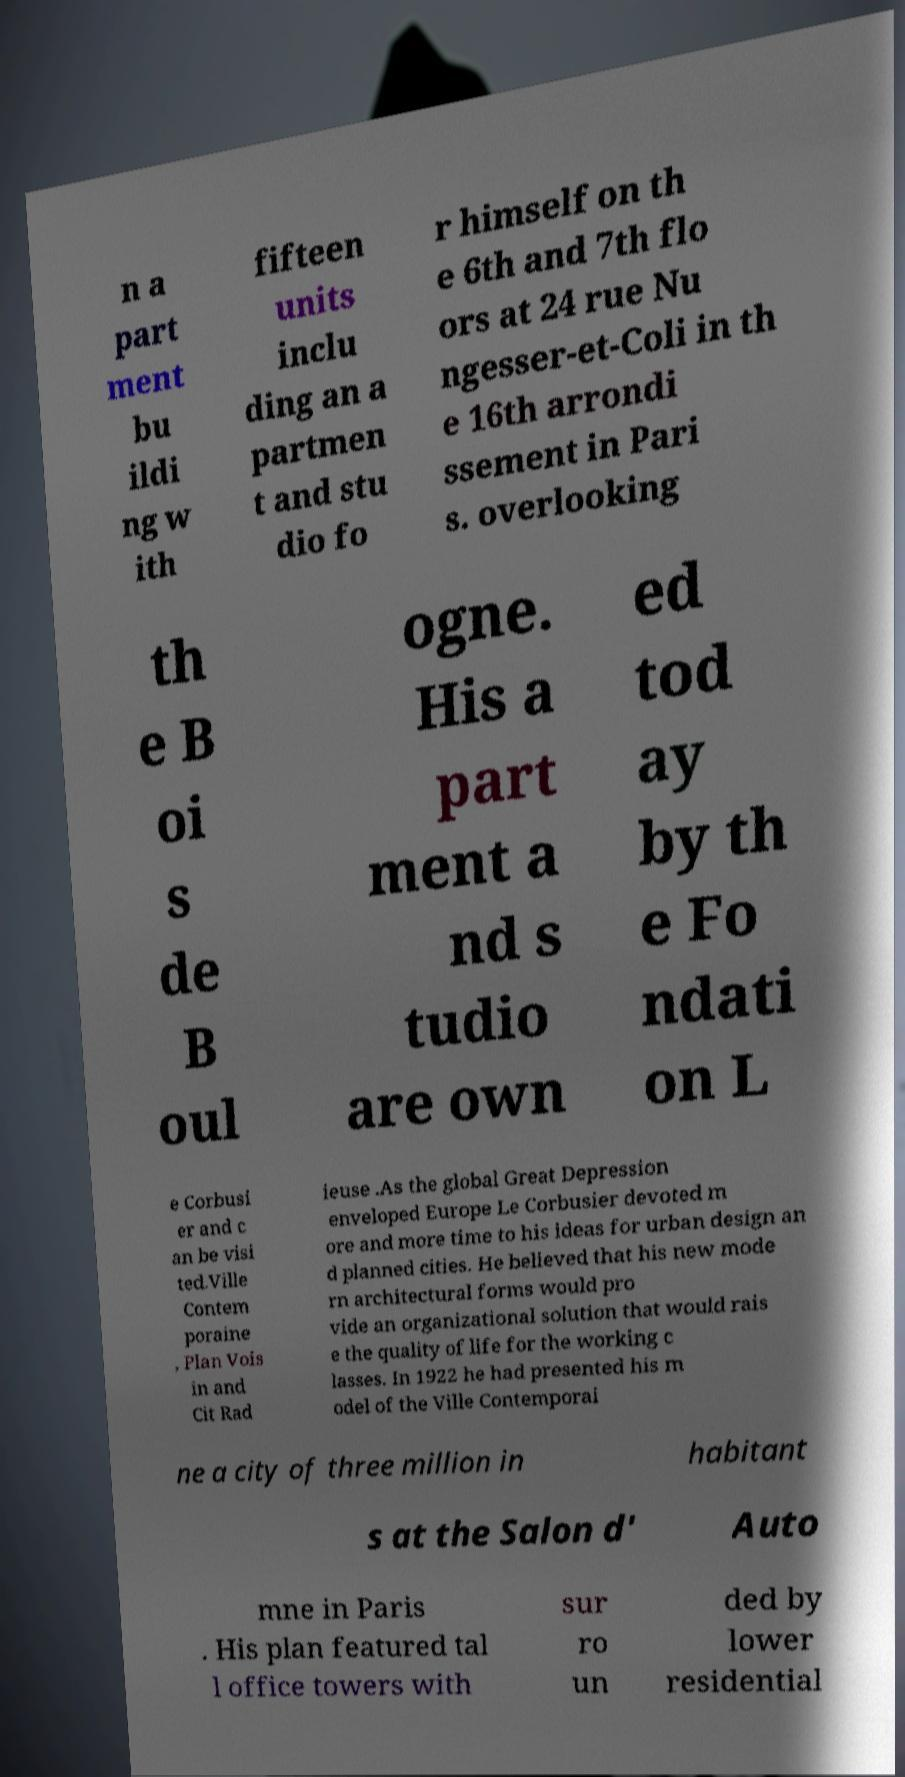Could you assist in decoding the text presented in this image and type it out clearly? n a part ment bu ildi ng w ith fifteen units inclu ding an a partmen t and stu dio fo r himself on th e 6th and 7th flo ors at 24 rue Nu ngesser-et-Coli in th e 16th arrondi ssement in Pari s. overlooking th e B oi s de B oul ogne. His a part ment a nd s tudio are own ed tod ay by th e Fo ndati on L e Corbusi er and c an be visi ted.Ville Contem poraine , Plan Vois in and Cit Rad ieuse .As the global Great Depression enveloped Europe Le Corbusier devoted m ore and more time to his ideas for urban design an d planned cities. He believed that his new mode rn architectural forms would pro vide an organizational solution that would rais e the quality of life for the working c lasses. In 1922 he had presented his m odel of the Ville Contemporai ne a city of three million in habitant s at the Salon d' Auto mne in Paris . His plan featured tal l office towers with sur ro un ded by lower residential 